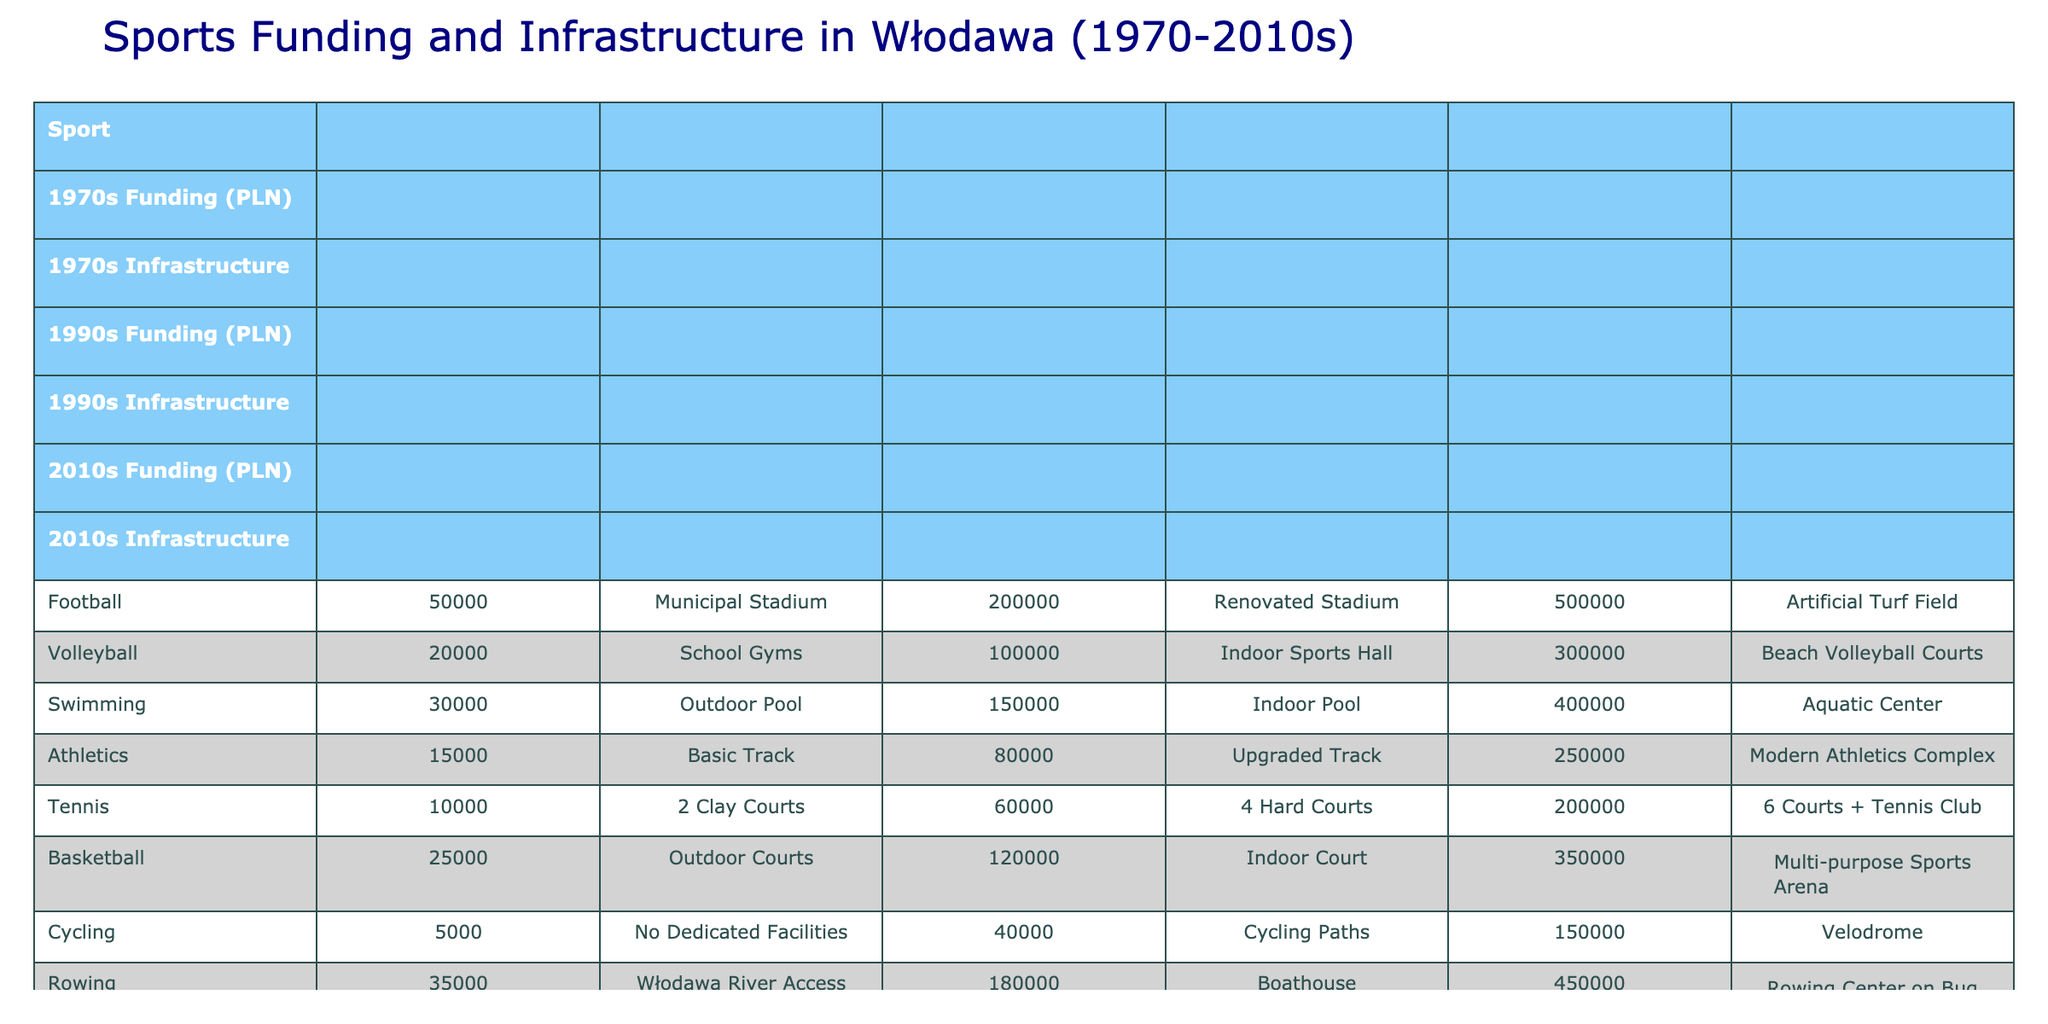What was the highest funding for a sport in the 2010s? The highest funding in the 2010s can be found by comparing the funding values in that column. The values are: Football (500000), Volleyball (300000), Swimming (400000), Athletics (250000), Tennis (200000), Basketball (350000), Cycling (150000), Rowing (450000), Chess (50000), and Table Tennis (180000). The maximum is 500000 for Football.
Answer: 500000 Which sport had the least funding in the 1970s? To find the sport with the least funding in the 1970s, compare the values in the "1970s Funding" column: Football (50000), Volleyball (20000), Swimming (30000), Athletics (15000), Tennis (10000), Basketball (25000), Cycling (5000), Rowing (35000), Chess (2000), and Table Tennis (8000). The minimum value is 2000 for Chess.
Answer: 2000 Was there an increase in funding for Volleyball from the 1990s to the 2010s? For Volleyball, the funding was 100000 in the 1990s and increased to 300000 in the 2010s. To determine if there was an increase, we see that 300000 is greater than 100000, indicating an increase.
Answer: Yes What is the total funding for all sports in the 1990s? The total funding is calculated by summing all values in the "1990s Funding" column: Football (200000), Volleyball (100000), Swimming (150000), Athletics (80000), Tennis (60000), Basketball (120000), Cycling (40000), Rowing (180000), Chess (15000), and Table Tennis (50000). The total is 200000 + 100000 + 150000 + 80000 + 60000 + 120000 + 40000 + 180000 + 15000 + 50000 = 1095000.
Answer: 1095000 Which sports had the same infrastructure type in the 2010s? To find sports with the same infrastructure type in the 2010s, we examine the "2010s Infrastructure" column: Artificial Turf Field (Football), Beach Volleyball Courts (Volleyball), Aquatic Center (Swimming), Modern Athletics Complex (Athletics), 6 Courts + Tennis Club (Tennis), Multi-purpose Sports Arena (Basketball), Velodrome (Cycling), Rowing Center on Bug River (Rowing), Chess Academy (Chess), and Table Tennis Training Center (Table Tennis). None of them have the same type.
Answer: No 